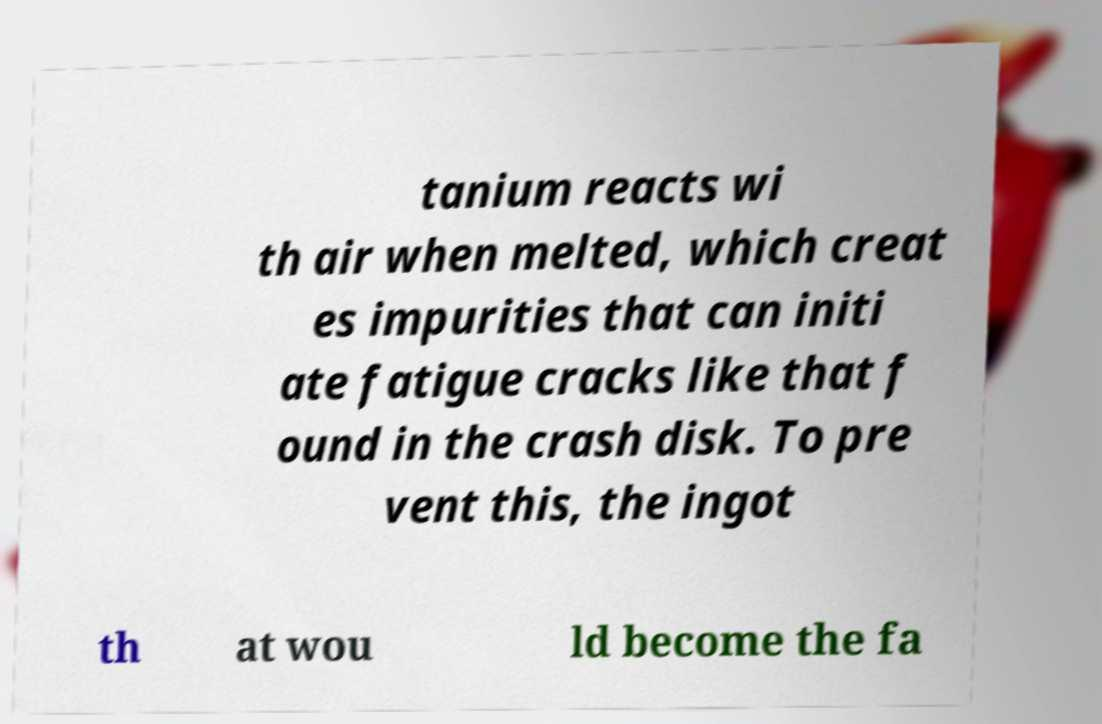Can you read and provide the text displayed in the image?This photo seems to have some interesting text. Can you extract and type it out for me? tanium reacts wi th air when melted, which creat es impurities that can initi ate fatigue cracks like that f ound in the crash disk. To pre vent this, the ingot th at wou ld become the fa 